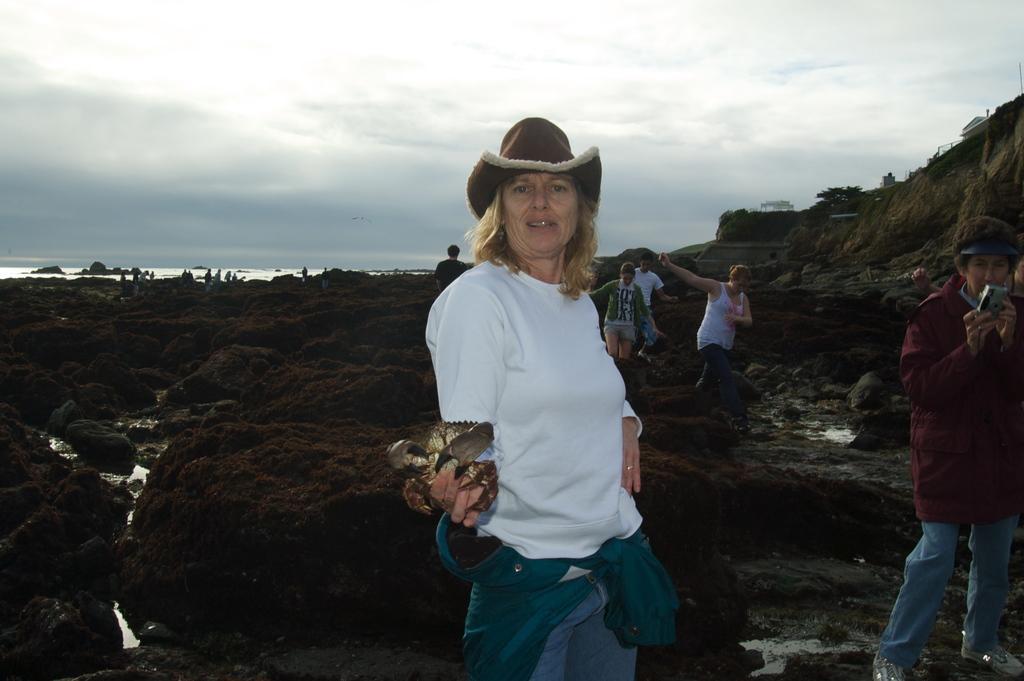How would you summarize this image in a sentence or two? In this picture we can see a group of people where some are standing and some are walking on rocks, camera, water and in the background we can see the sky with clouds. 